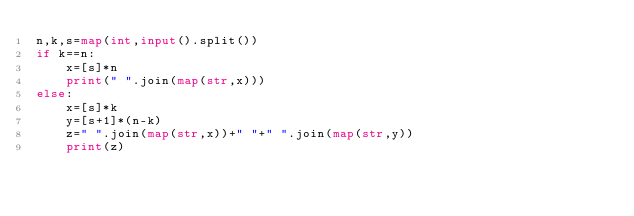Convert code to text. <code><loc_0><loc_0><loc_500><loc_500><_Python_>n,k,s=map(int,input().split())
if k==n:
    x=[s]*n
    print(" ".join(map(str,x)))
else:
    x=[s]*k
    y=[s+1]*(n-k)
    z=" ".join(map(str,x))+" "+" ".join(map(str,y))
    print(z)
</code> 